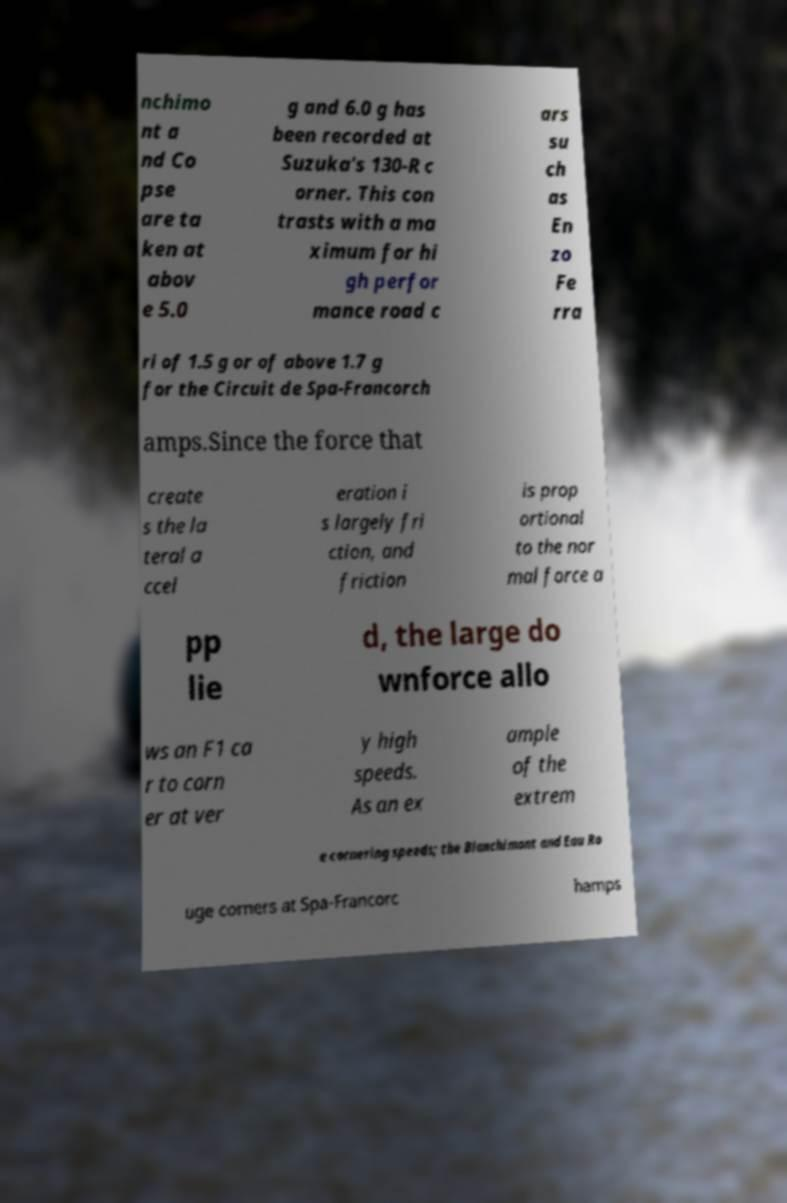I need the written content from this picture converted into text. Can you do that? nchimo nt a nd Co pse are ta ken at abov e 5.0 g and 6.0 g has been recorded at Suzuka's 130-R c orner. This con trasts with a ma ximum for hi gh perfor mance road c ars su ch as En zo Fe rra ri of 1.5 g or of above 1.7 g for the Circuit de Spa-Francorch amps.Since the force that create s the la teral a ccel eration i s largely fri ction, and friction is prop ortional to the nor mal force a pp lie d, the large do wnforce allo ws an F1 ca r to corn er at ver y high speeds. As an ex ample of the extrem e cornering speeds; the Blanchimont and Eau Ro uge corners at Spa-Francorc hamps 